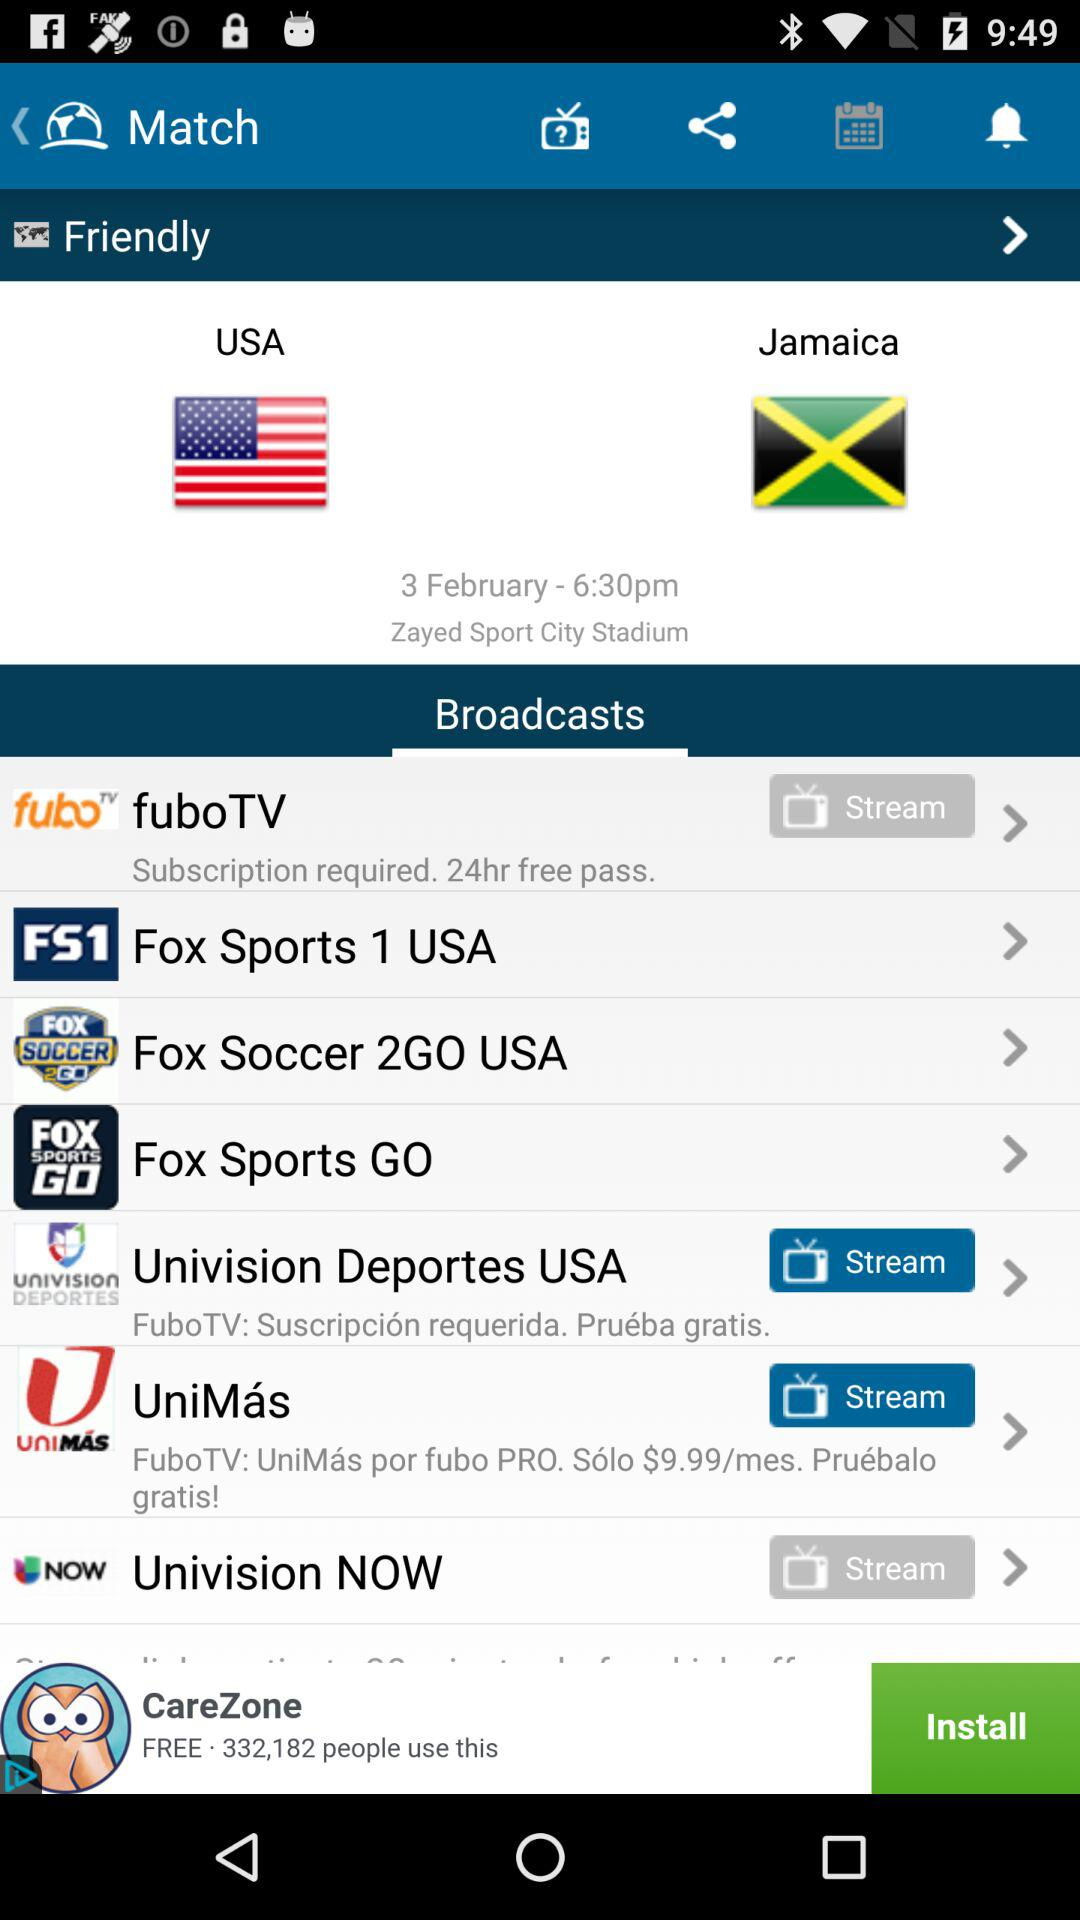What type of match will be played between "USA" and "Jamaica"? The type of match is "Friendly". 